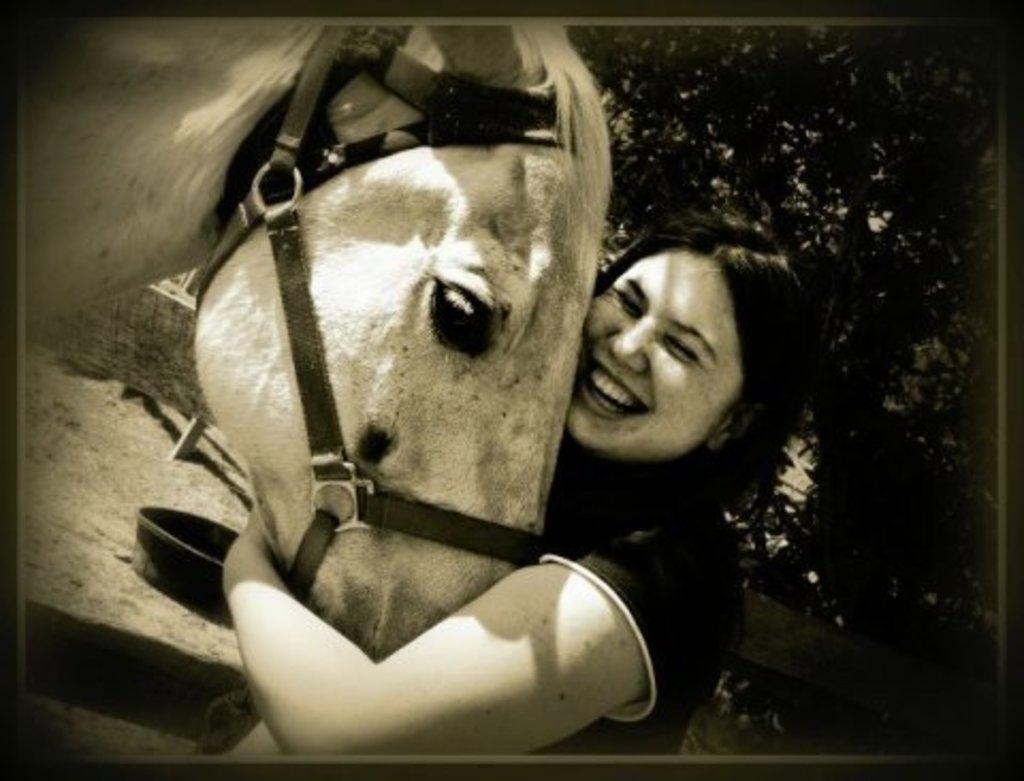Describe this image in one or two sentences. This a black and white picture. We can see a women holding a smile on her face and she is holding an animal with her hands. This is a tub. On the background we can see trees. 